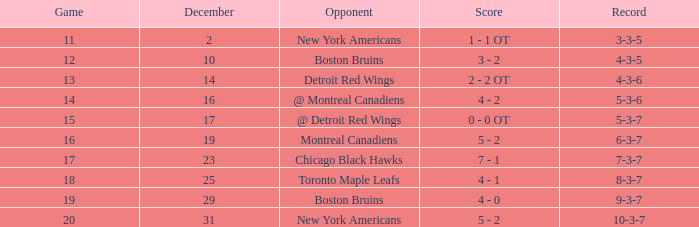Which December has a Record of 4-3-6? 14.0. 